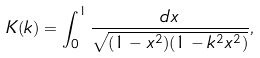<formula> <loc_0><loc_0><loc_500><loc_500>K ( k ) = \int ^ { 1 } _ { 0 } \frac { d x } { \sqrt { ( 1 - x ^ { 2 } ) ( 1 - k ^ { 2 } x ^ { 2 } ) } } ,</formula> 